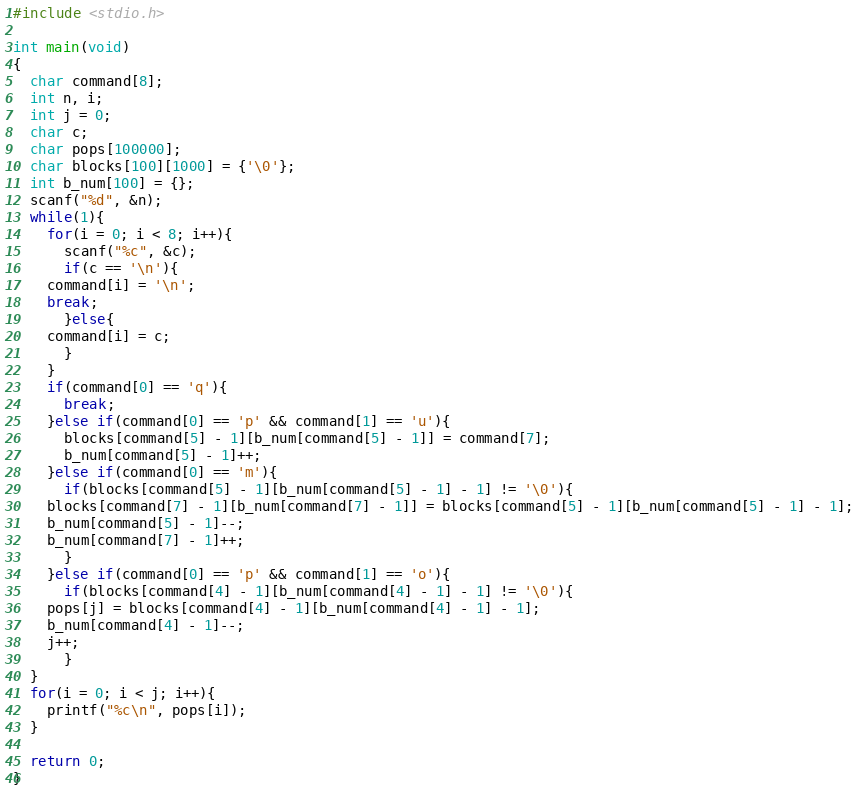<code> <loc_0><loc_0><loc_500><loc_500><_C_>#include <stdio.h>

int main(void)
{
  char command[8];
  int n, i;
  int j = 0;
  char c;
  char pops[100000];
  char blocks[100][1000] = {'\0'};
  int b_num[100] = {};
  scanf("%d", &n);
  while(1){
    for(i = 0; i < 8; i++){
      scanf("%c", &c);
      if(c == '\n'){
	command[i] = '\n';
	break;
      }else{
	command[i] = c;
      }
    }
    if(command[0] == 'q'){
      break;
    }else if(command[0] == 'p' && command[1] == 'u'){
      blocks[command[5] - 1][b_num[command[5] - 1]] = command[7];
      b_num[command[5] - 1]++;
    }else if(command[0] == 'm'){
      if(blocks[command[5] - 1][b_num[command[5] - 1] - 1] != '\0'){
	blocks[command[7] - 1][b_num[command[7] - 1]] = blocks[command[5] - 1][b_num[command[5] - 1] - 1];
	b_num[command[5] - 1]--;
	b_num[command[7] - 1]++;
      }
    }else if(command[0] == 'p' && command[1] == 'o'){
      if(blocks[command[4] - 1][b_num[command[4] - 1] - 1] != '\0'){
	pops[j] = blocks[command[4] - 1][b_num[command[4] - 1] - 1];
	b_num[command[4] - 1]--;
	j++;	
      }
  }
  for(i = 0; i < j; i++){
    printf("%c\n", pops[i]);
  }
  
  return 0;
}</code> 